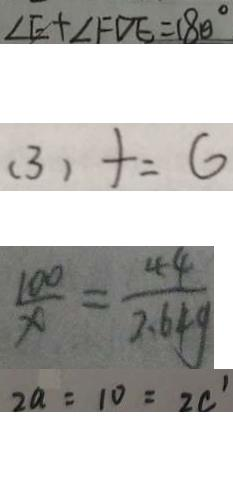<formula> <loc_0><loc_0><loc_500><loc_500>\angle E + \angle F D E = 1 8 0 ^ { \circ } 
 ( 3 ) + = 6 
 \frac { 1 0 0 } { x } = \frac { 4 4 } { 2 . 6 4 g } 
 2 a = 1 0 = 2 c ^ { \prime }</formula> 